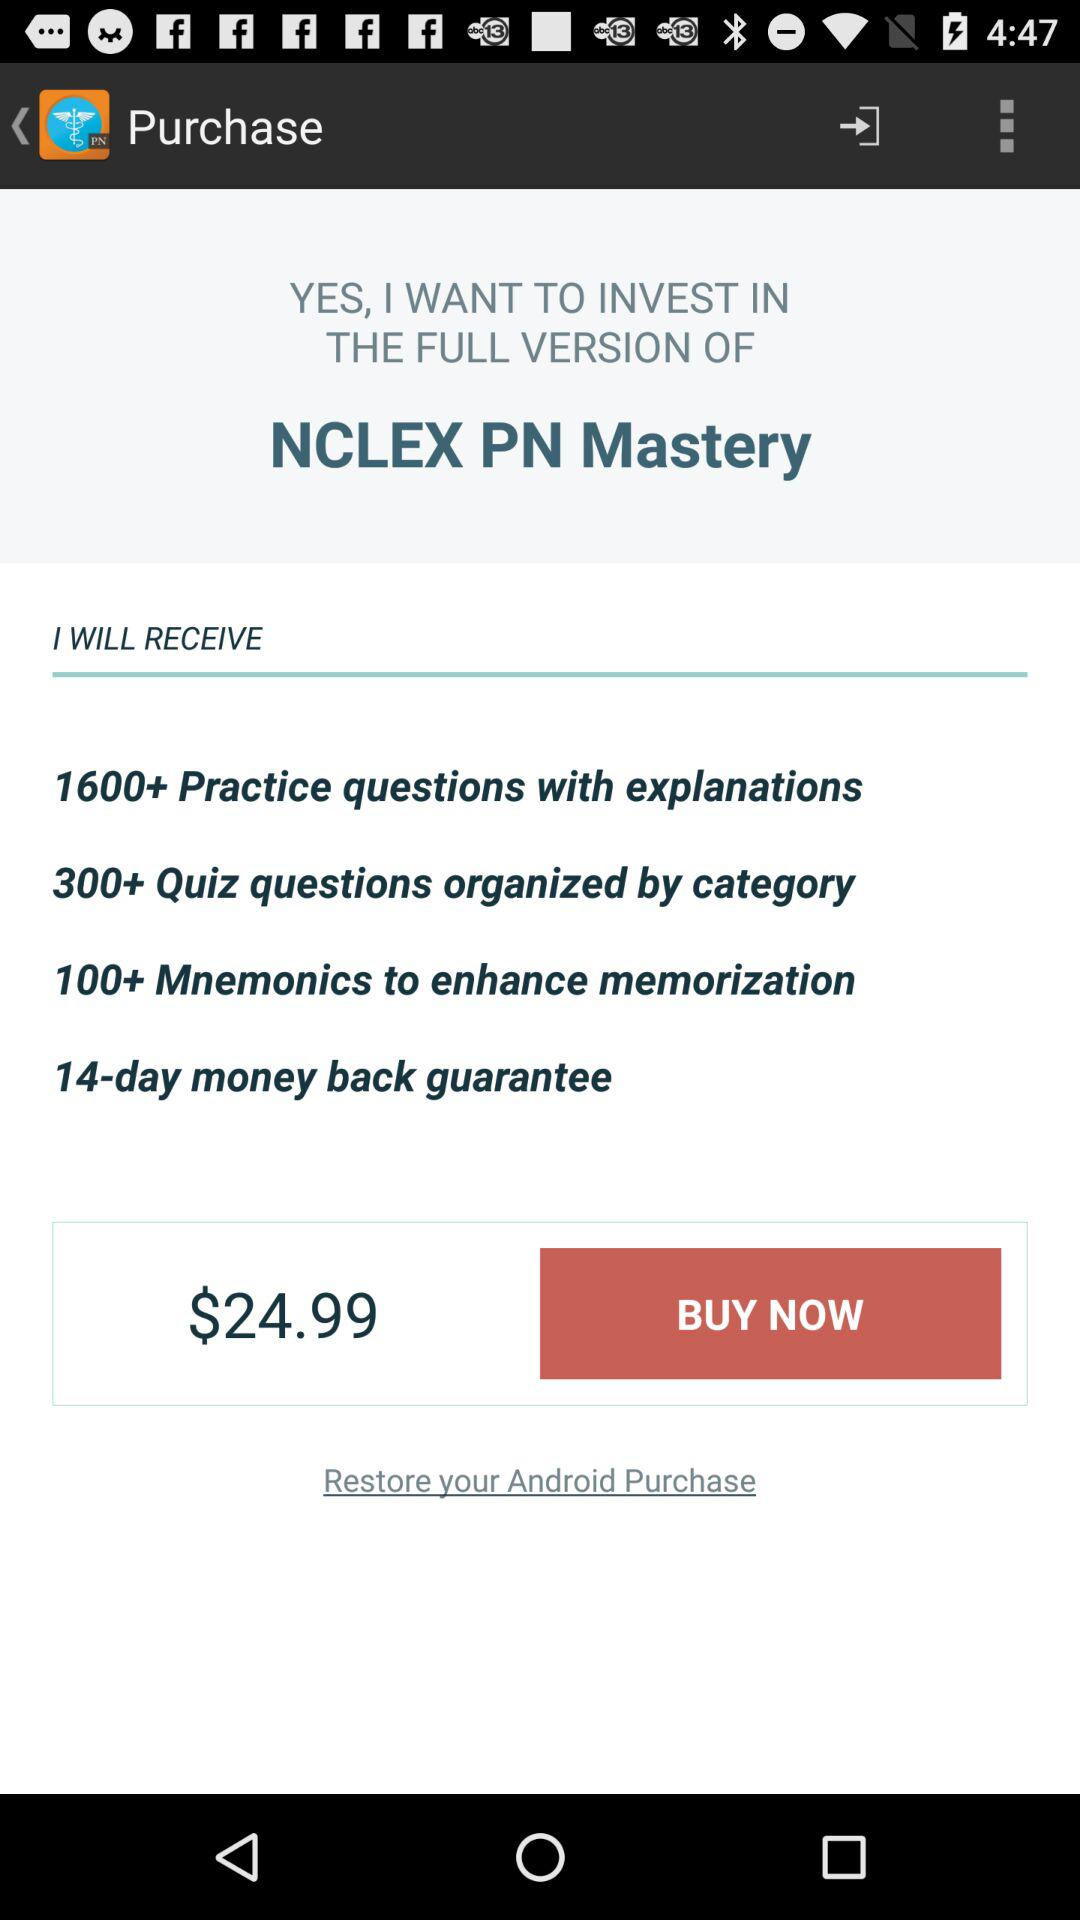How many quiz questions are there? There are more than 300 quiz questions. 